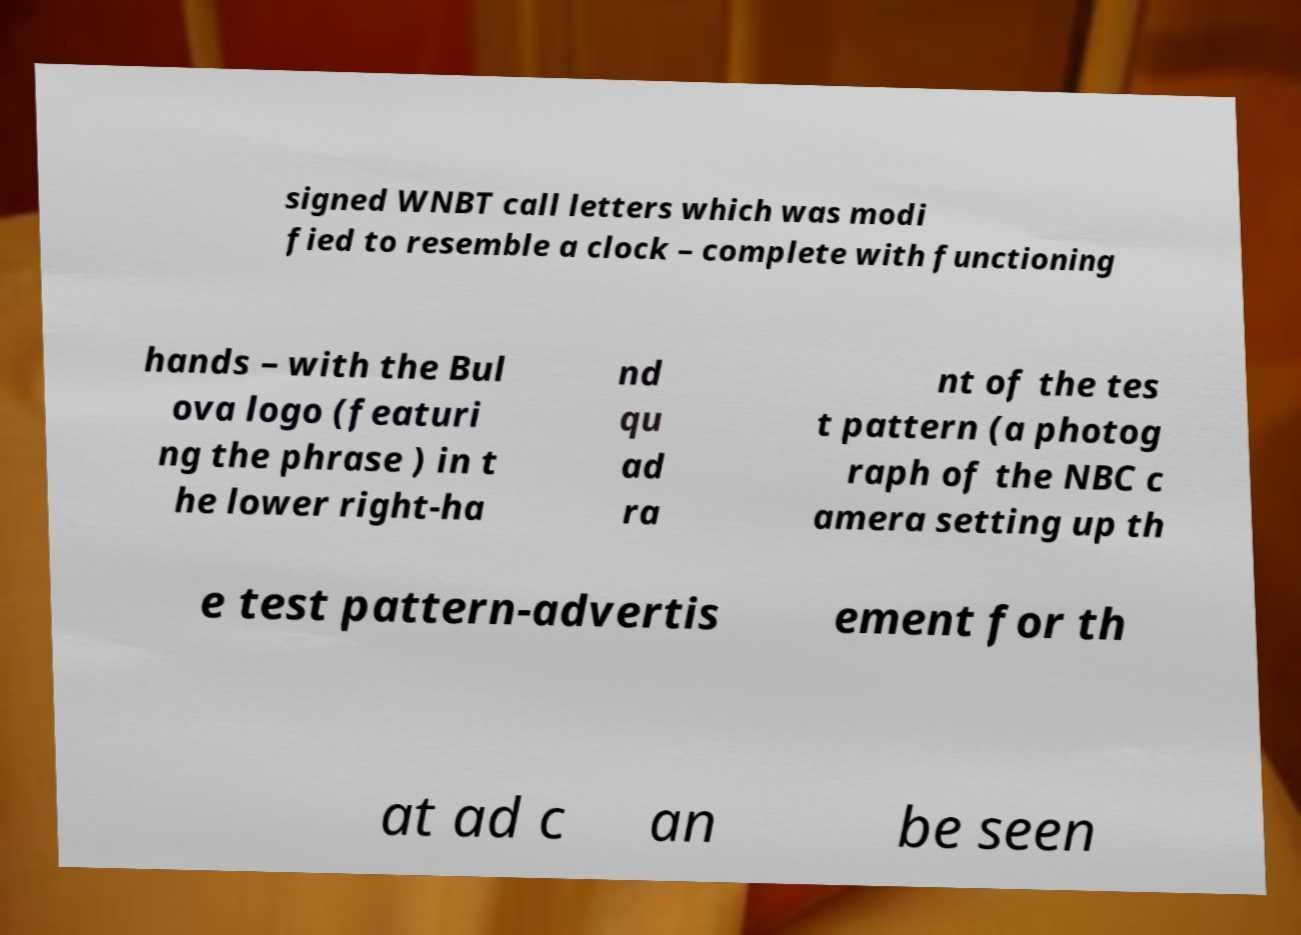Please read and relay the text visible in this image. What does it say? signed WNBT call letters which was modi fied to resemble a clock – complete with functioning hands – with the Bul ova logo (featuri ng the phrase ) in t he lower right-ha nd qu ad ra nt of the tes t pattern (a photog raph of the NBC c amera setting up th e test pattern-advertis ement for th at ad c an be seen 